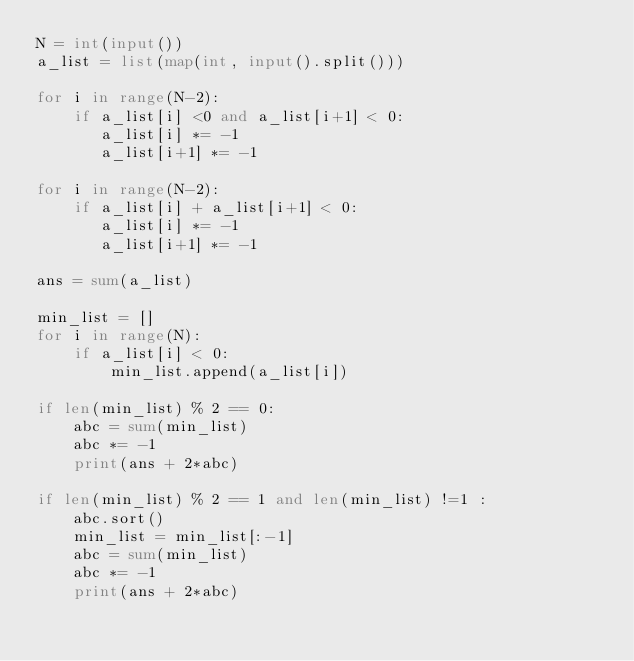<code> <loc_0><loc_0><loc_500><loc_500><_Python_>N = int(input())
a_list = list(map(int, input().split()))

for i in range(N-2):
    if a_list[i] <0 and a_list[i+1] < 0:
       a_list[i] *= -1
       a_list[i+1] *= -1

for i in range(N-2):
    if a_list[i] + a_list[i+1] < 0:
       a_list[i] *= -1
       a_list[i+1] *= -1

ans = sum(a_list)

min_list = []
for i in range(N):
    if a_list[i] < 0:
        min_list.append(a_list[i])

if len(min_list) % 2 == 0:
    abc = sum(min_list)
    abc *= -1
    print(ans + 2*abc)

if len(min_list) % 2 == 1 and len(min_list) !=1 :
    abc.sort()
    min_list = min_list[:-1]
    abc = sum(min_list)
    abc *= -1
    print(ans + 2*abc)</code> 